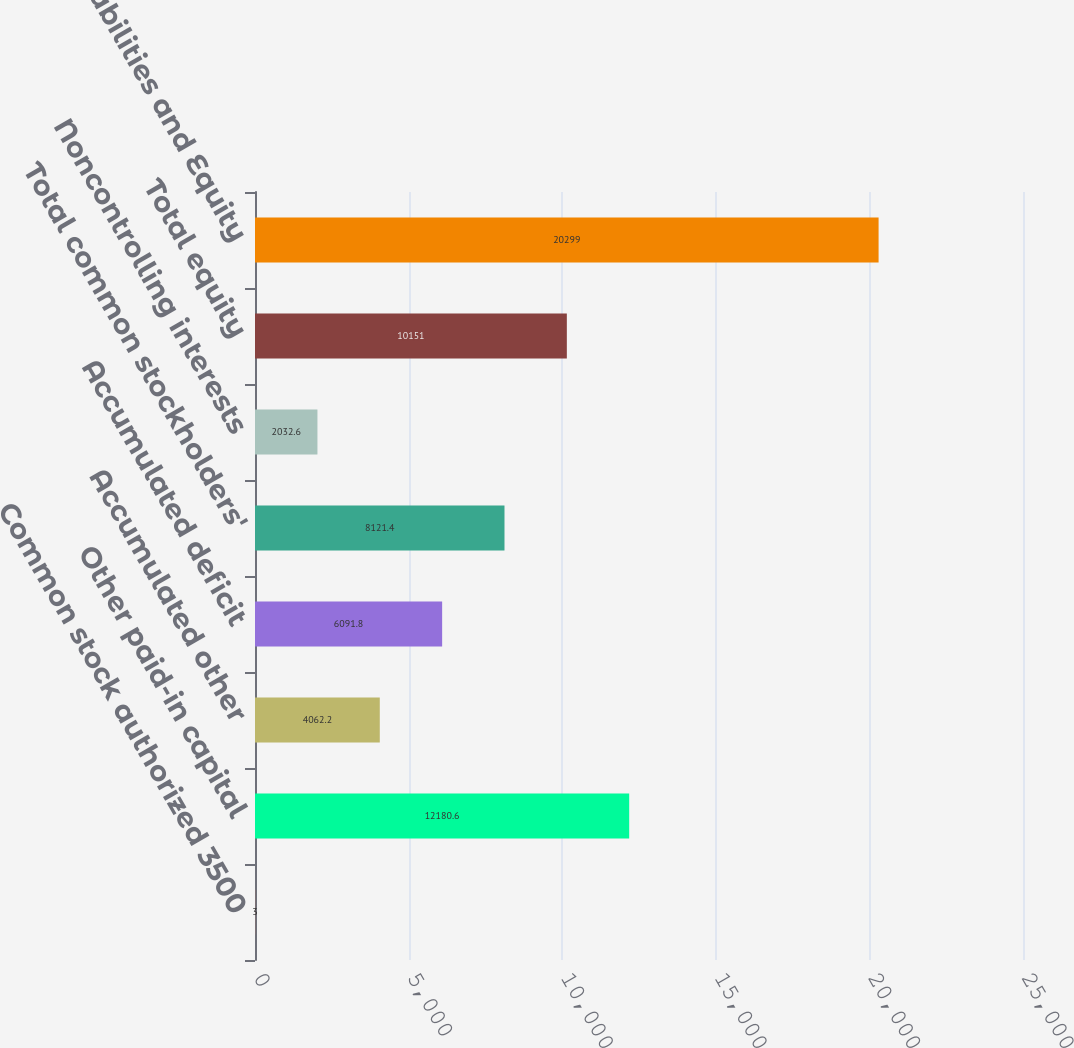Convert chart to OTSL. <chart><loc_0><loc_0><loc_500><loc_500><bar_chart><fcel>Common stock authorized 3500<fcel>Other paid-in capital<fcel>Accumulated other<fcel>Accumulated deficit<fcel>Total common stockholders'<fcel>Noncontrolling interests<fcel>Total equity<fcel>Total Liabilities and Equity<nl><fcel>3<fcel>12180.6<fcel>4062.2<fcel>6091.8<fcel>8121.4<fcel>2032.6<fcel>10151<fcel>20299<nl></chart> 